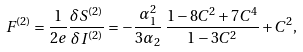Convert formula to latex. <formula><loc_0><loc_0><loc_500><loc_500>F ^ { ( 2 ) } = \frac { 1 } { 2 e } \frac { \delta S ^ { ( 2 ) } } { \delta I ^ { ( 2 ) } } = - \frac { \alpha _ { 1 } ^ { 2 } } { 3 \alpha _ { 2 } } \, \frac { 1 - 8 C ^ { 2 } + 7 C ^ { 4 } } { 1 - 3 C ^ { 2 } } + C ^ { 2 } ,</formula> 